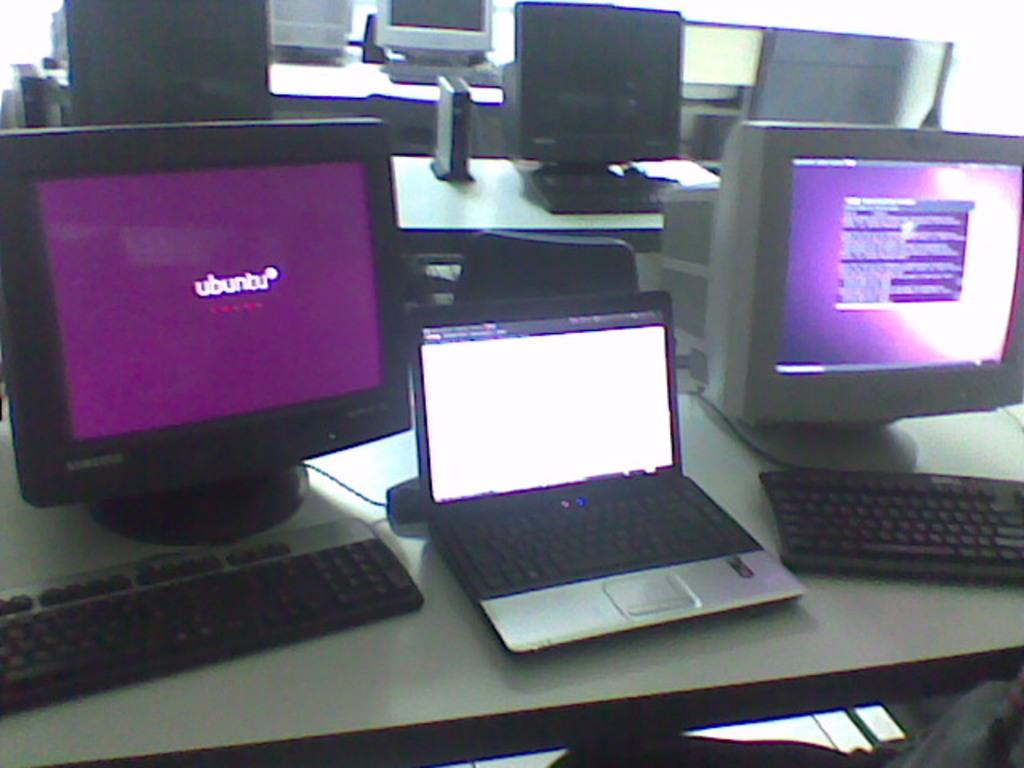<image>
Give a short and clear explanation of the subsequent image. Ubunbu is the browser showing on the monitor of one of the computers on the closest desk. 